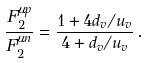<formula> <loc_0><loc_0><loc_500><loc_500>\frac { F _ { 2 } ^ { \mu p } } { F _ { 2 } ^ { \mu n } } = \frac { 1 + 4 d _ { v } / u _ { v } } { 4 + d _ { v } / u _ { v } } \, .</formula> 